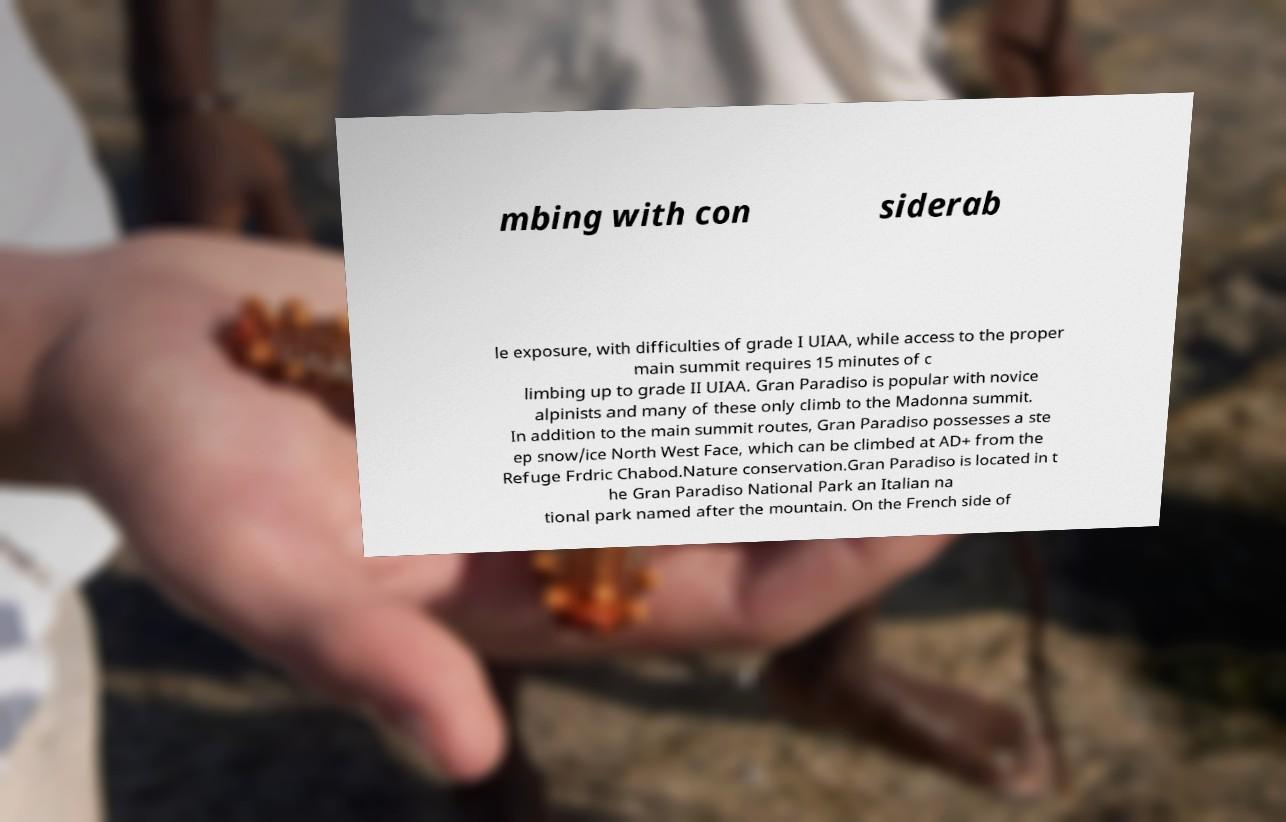Please read and relay the text visible in this image. What does it say? mbing with con siderab le exposure, with difficulties of grade I UIAA, while access to the proper main summit requires 15 minutes of c limbing up to grade II UIAA. Gran Paradiso is popular with novice alpinists and many of these only climb to the Madonna summit. In addition to the main summit routes, Gran Paradiso possesses a ste ep snow/ice North West Face, which can be climbed at AD+ from the Refuge Frdric Chabod.Nature conservation.Gran Paradiso is located in t he Gran Paradiso National Park an Italian na tional park named after the mountain. On the French side of 